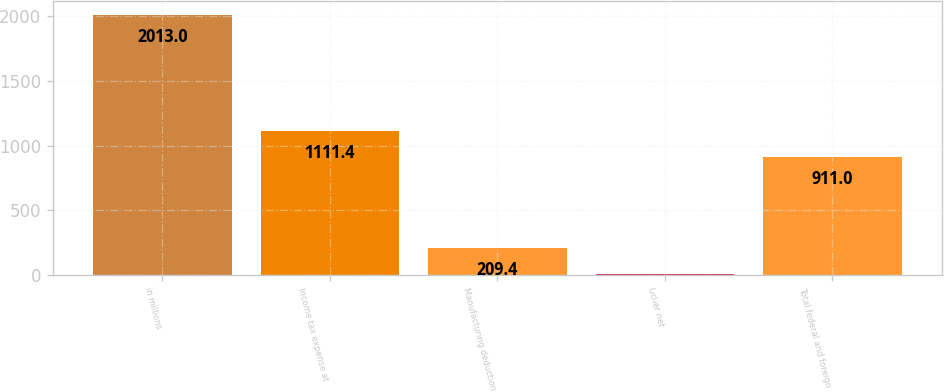Convert chart. <chart><loc_0><loc_0><loc_500><loc_500><bar_chart><fcel>in millions<fcel>Income tax expense at<fcel>Manufacturing deduction<fcel>Other net<fcel>Total federal and foreign<nl><fcel>2013<fcel>1111.4<fcel>209.4<fcel>9<fcel>911<nl></chart> 